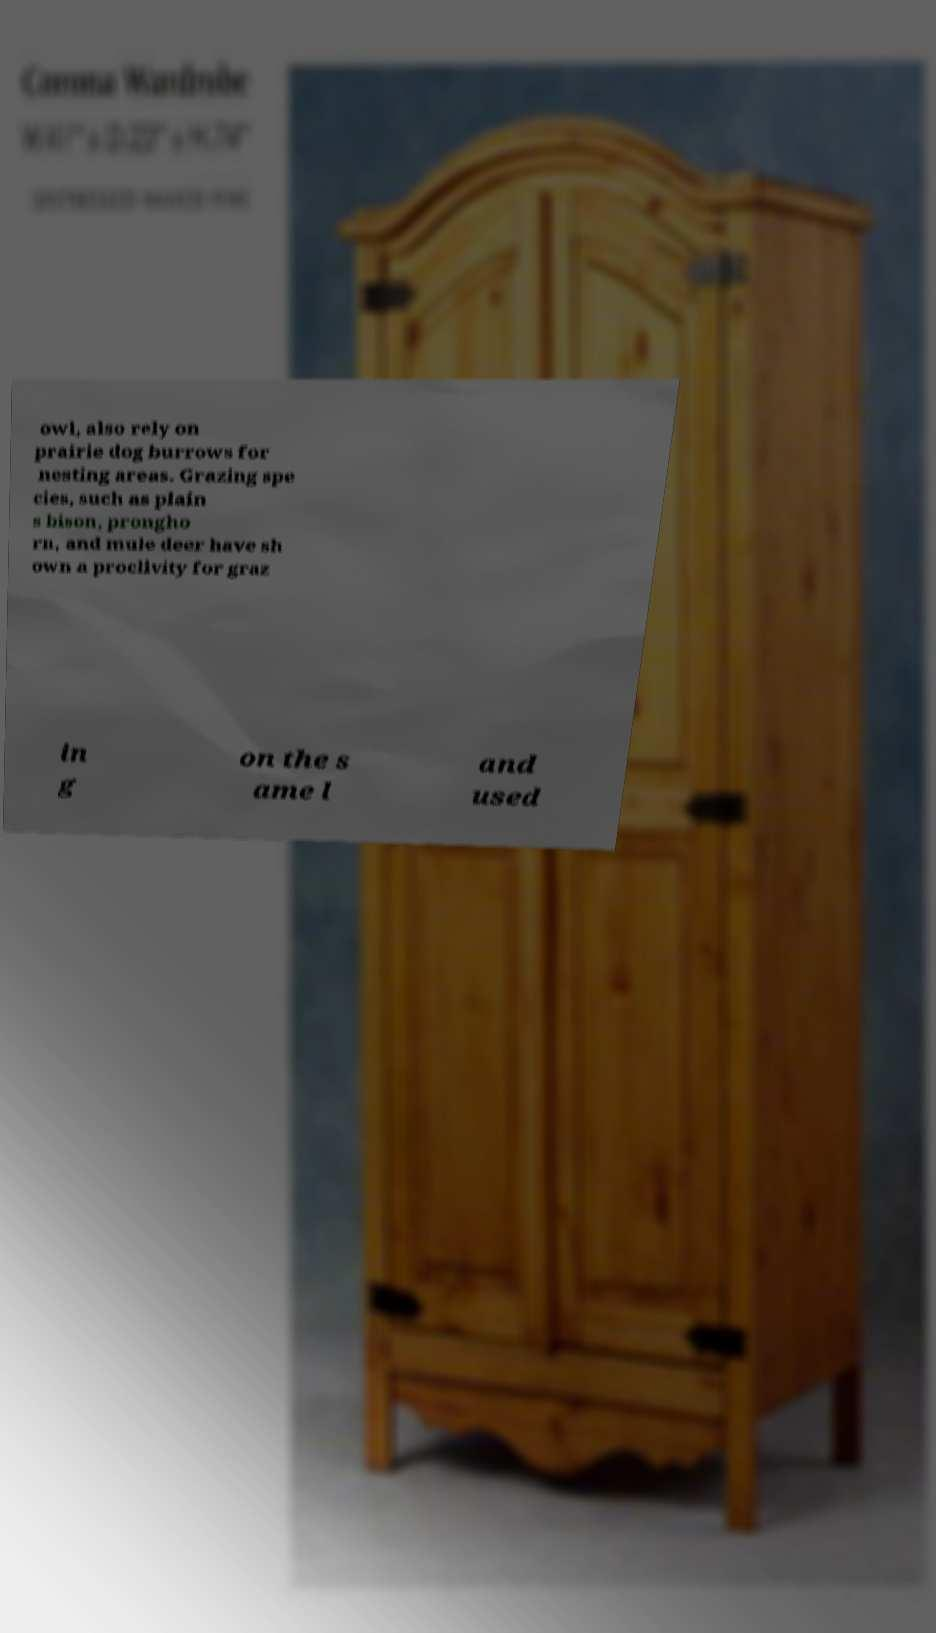What messages or text are displayed in this image? I need them in a readable, typed format. owl, also rely on prairie dog burrows for nesting areas. Grazing spe cies, such as plain s bison, prongho rn, and mule deer have sh own a proclivity for graz in g on the s ame l and used 